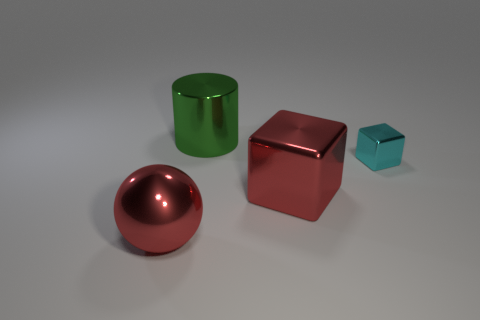Add 1 big blue matte cubes. How many objects exist? 5 Subtract all green cubes. How many yellow balls are left? 0 Subtract all red blocks. How many blocks are left? 1 Subtract 1 cyan cubes. How many objects are left? 3 Subtract all cylinders. How many objects are left? 3 Subtract 2 cubes. How many cubes are left? 0 Subtract all brown cylinders. Subtract all cyan blocks. How many cylinders are left? 1 Subtract all large metallic balls. Subtract all red metal objects. How many objects are left? 1 Add 1 cyan objects. How many cyan objects are left? 2 Add 3 purple spheres. How many purple spheres exist? 3 